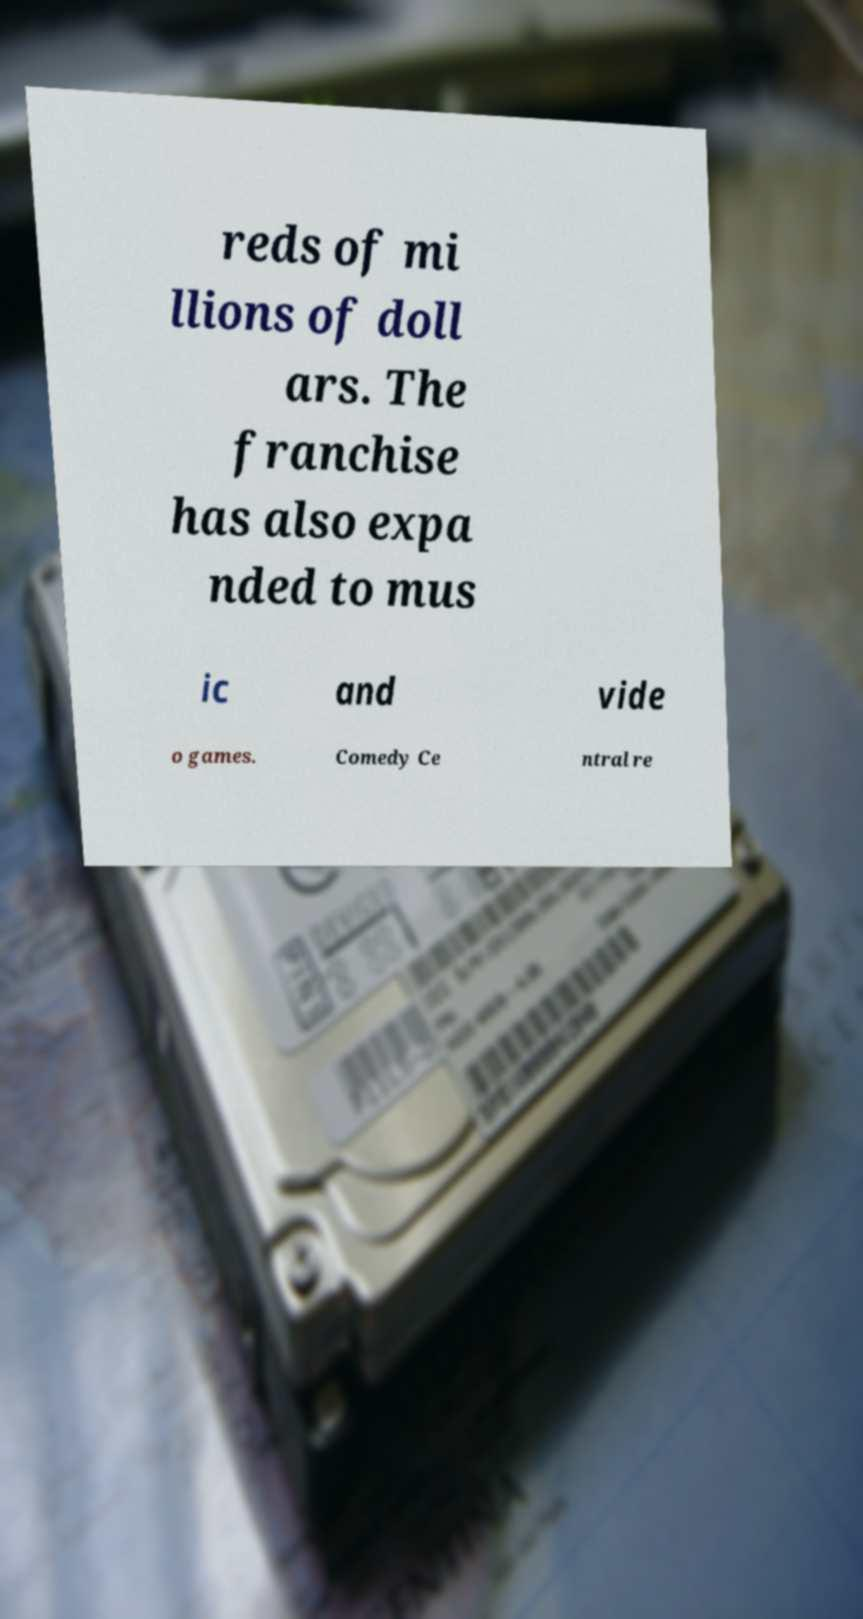For documentation purposes, I need the text within this image transcribed. Could you provide that? reds of mi llions of doll ars. The franchise has also expa nded to mus ic and vide o games. Comedy Ce ntral re 